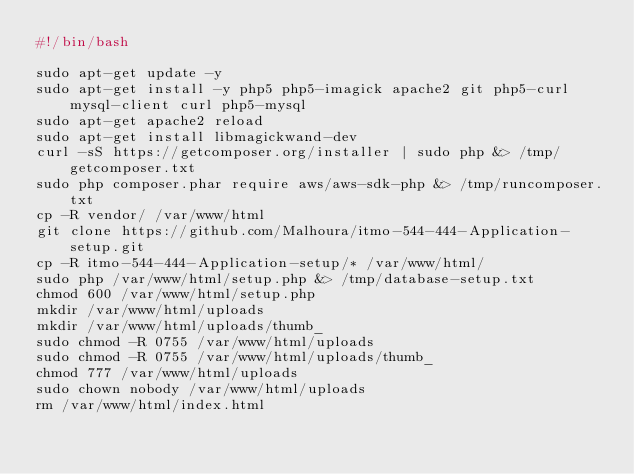Convert code to text. <code><loc_0><loc_0><loc_500><loc_500><_Bash_>#!/bin/bash

sudo apt-get update -y
sudo apt-get install -y php5 php5-imagick apache2 git php5-curl mysql-client curl php5-mysql 
sudo apt-get apache2 reload
sudo apt-get install libmagickwand-dev
curl -sS https://getcomposer.org/installer | sudo php &> /tmp/getcomposer.txt
sudo php composer.phar require aws/aws-sdk-php &> /tmp/runcomposer.txt
cp -R vendor/ /var/www/html
git clone https://github.com/Malhoura/itmo-544-444-Application-setup.git
cp -R itmo-544-444-Application-setup/* /var/www/html/
sudo php /var/www/html/setup.php &> /tmp/database-setup.txt
chmod 600 /var/www/html/setup.php
mkdir /var/www/html/uploads
mkdir /var/www/html/uploads/thumb_
sudo chmod -R 0755 /var/www/html/uploads
sudo chmod -R 0755 /var/www/html/uploads/thumb_
chmod 777 /var/www/html/uploads
sudo chown nobody /var/www/html/uploads
rm /var/www/html/index.html
</code> 